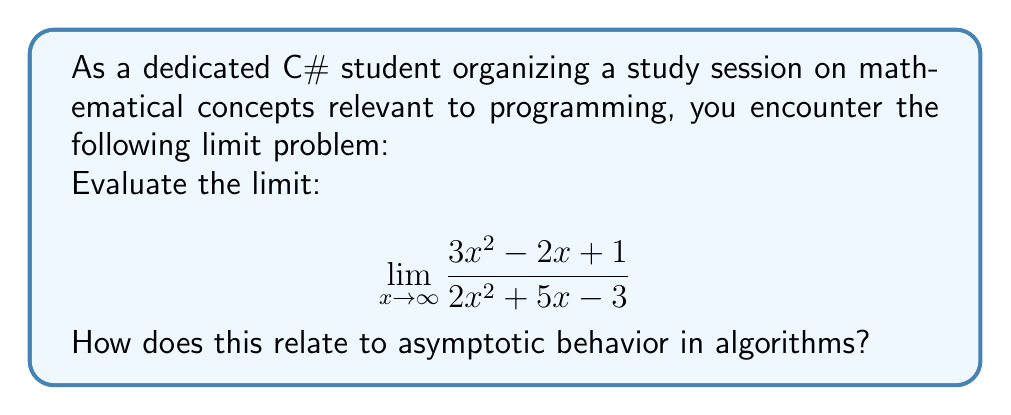Give your solution to this math problem. Let's approach this step-by-step:

1) When evaluating limits of rational functions as x approaches infinity, we focus on the highest degree terms in both numerator and denominator.

2) In this case, the highest degree term in both numerator and denominator is $x^2$.

3) We can factor out $x^2$ from both numerator and denominator:

   $$ \lim_{x \to \infty} \frac{x^2(3 - \frac{2}{x} + \frac{1}{x^2})}{x^2(2 + \frac{5}{x} - \frac{3}{x^2})} $$

4) As $x$ approaches infinity, $\frac{1}{x}$ and $\frac{1}{x^2}$ approach 0, so we can simplify:

   $$ \lim_{x \to \infty} \frac{x^2(3)}{x^2(2)} = \frac{3}{2} $$

5) The $x^2$ terms cancel out, leaving us with the ratio of the coefficients of the highest degree terms.

Relating to C# and algorithms:
This concept is crucial in understanding the asymptotic behavior of algorithms. In Big O notation, we often ignore lower-order terms and constants, focusing on the highest-order term, similar to how we evaluated this limit. For example, an algorithm with time complexity $3n^2 - 2n + 1$ would be considered $O(n^2)$, just as this limit focused on the $x^2$ terms.
Answer: $\frac{3}{2}$ 